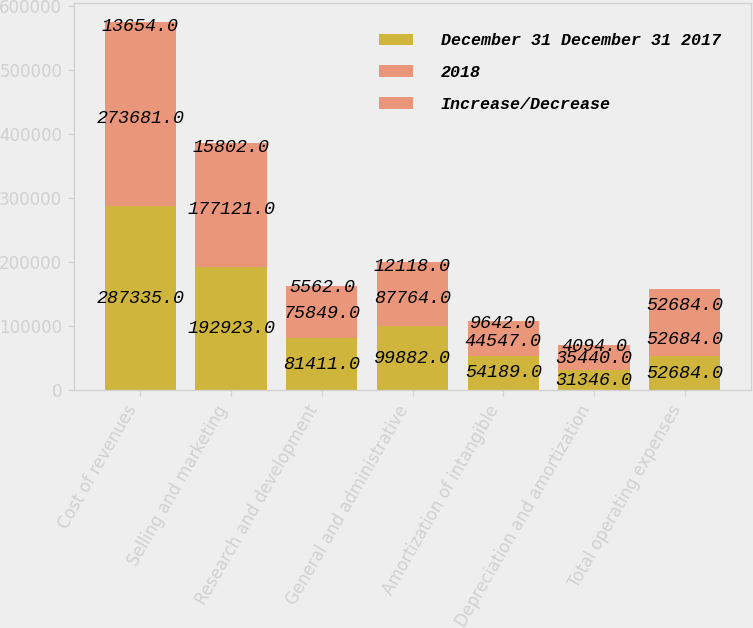<chart> <loc_0><loc_0><loc_500><loc_500><stacked_bar_chart><ecel><fcel>Cost of revenues<fcel>Selling and marketing<fcel>Research and development<fcel>General and administrative<fcel>Amortization of intangible<fcel>Depreciation and amortization<fcel>Total operating expenses<nl><fcel>December 31 December 31 2017<fcel>287335<fcel>192923<fcel>81411<fcel>99882<fcel>54189<fcel>31346<fcel>52684<nl><fcel>2018<fcel>273681<fcel>177121<fcel>75849<fcel>87764<fcel>44547<fcel>35440<fcel>52684<nl><fcel>Increase/Decrease<fcel>13654<fcel>15802<fcel>5562<fcel>12118<fcel>9642<fcel>4094<fcel>52684<nl></chart> 